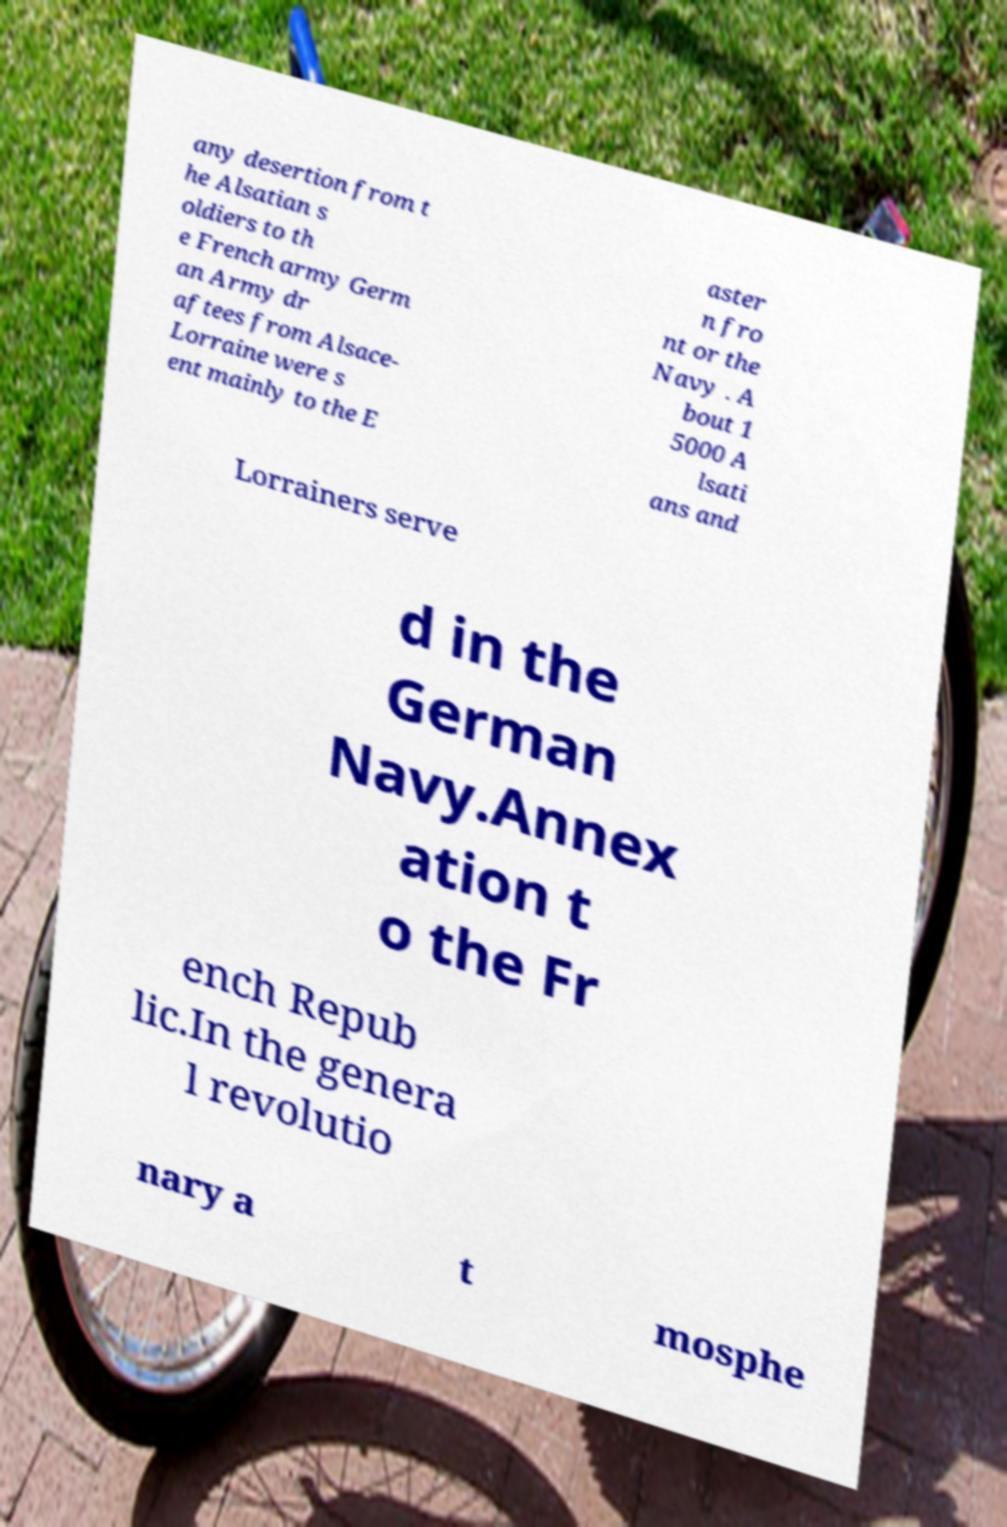What messages or text are displayed in this image? I need them in a readable, typed format. any desertion from t he Alsatian s oldiers to th e French army Germ an Army dr aftees from Alsace- Lorraine were s ent mainly to the E aster n fro nt or the Navy . A bout 1 5000 A lsati ans and Lorrainers serve d in the German Navy.Annex ation t o the Fr ench Repub lic.In the genera l revolutio nary a t mosphe 